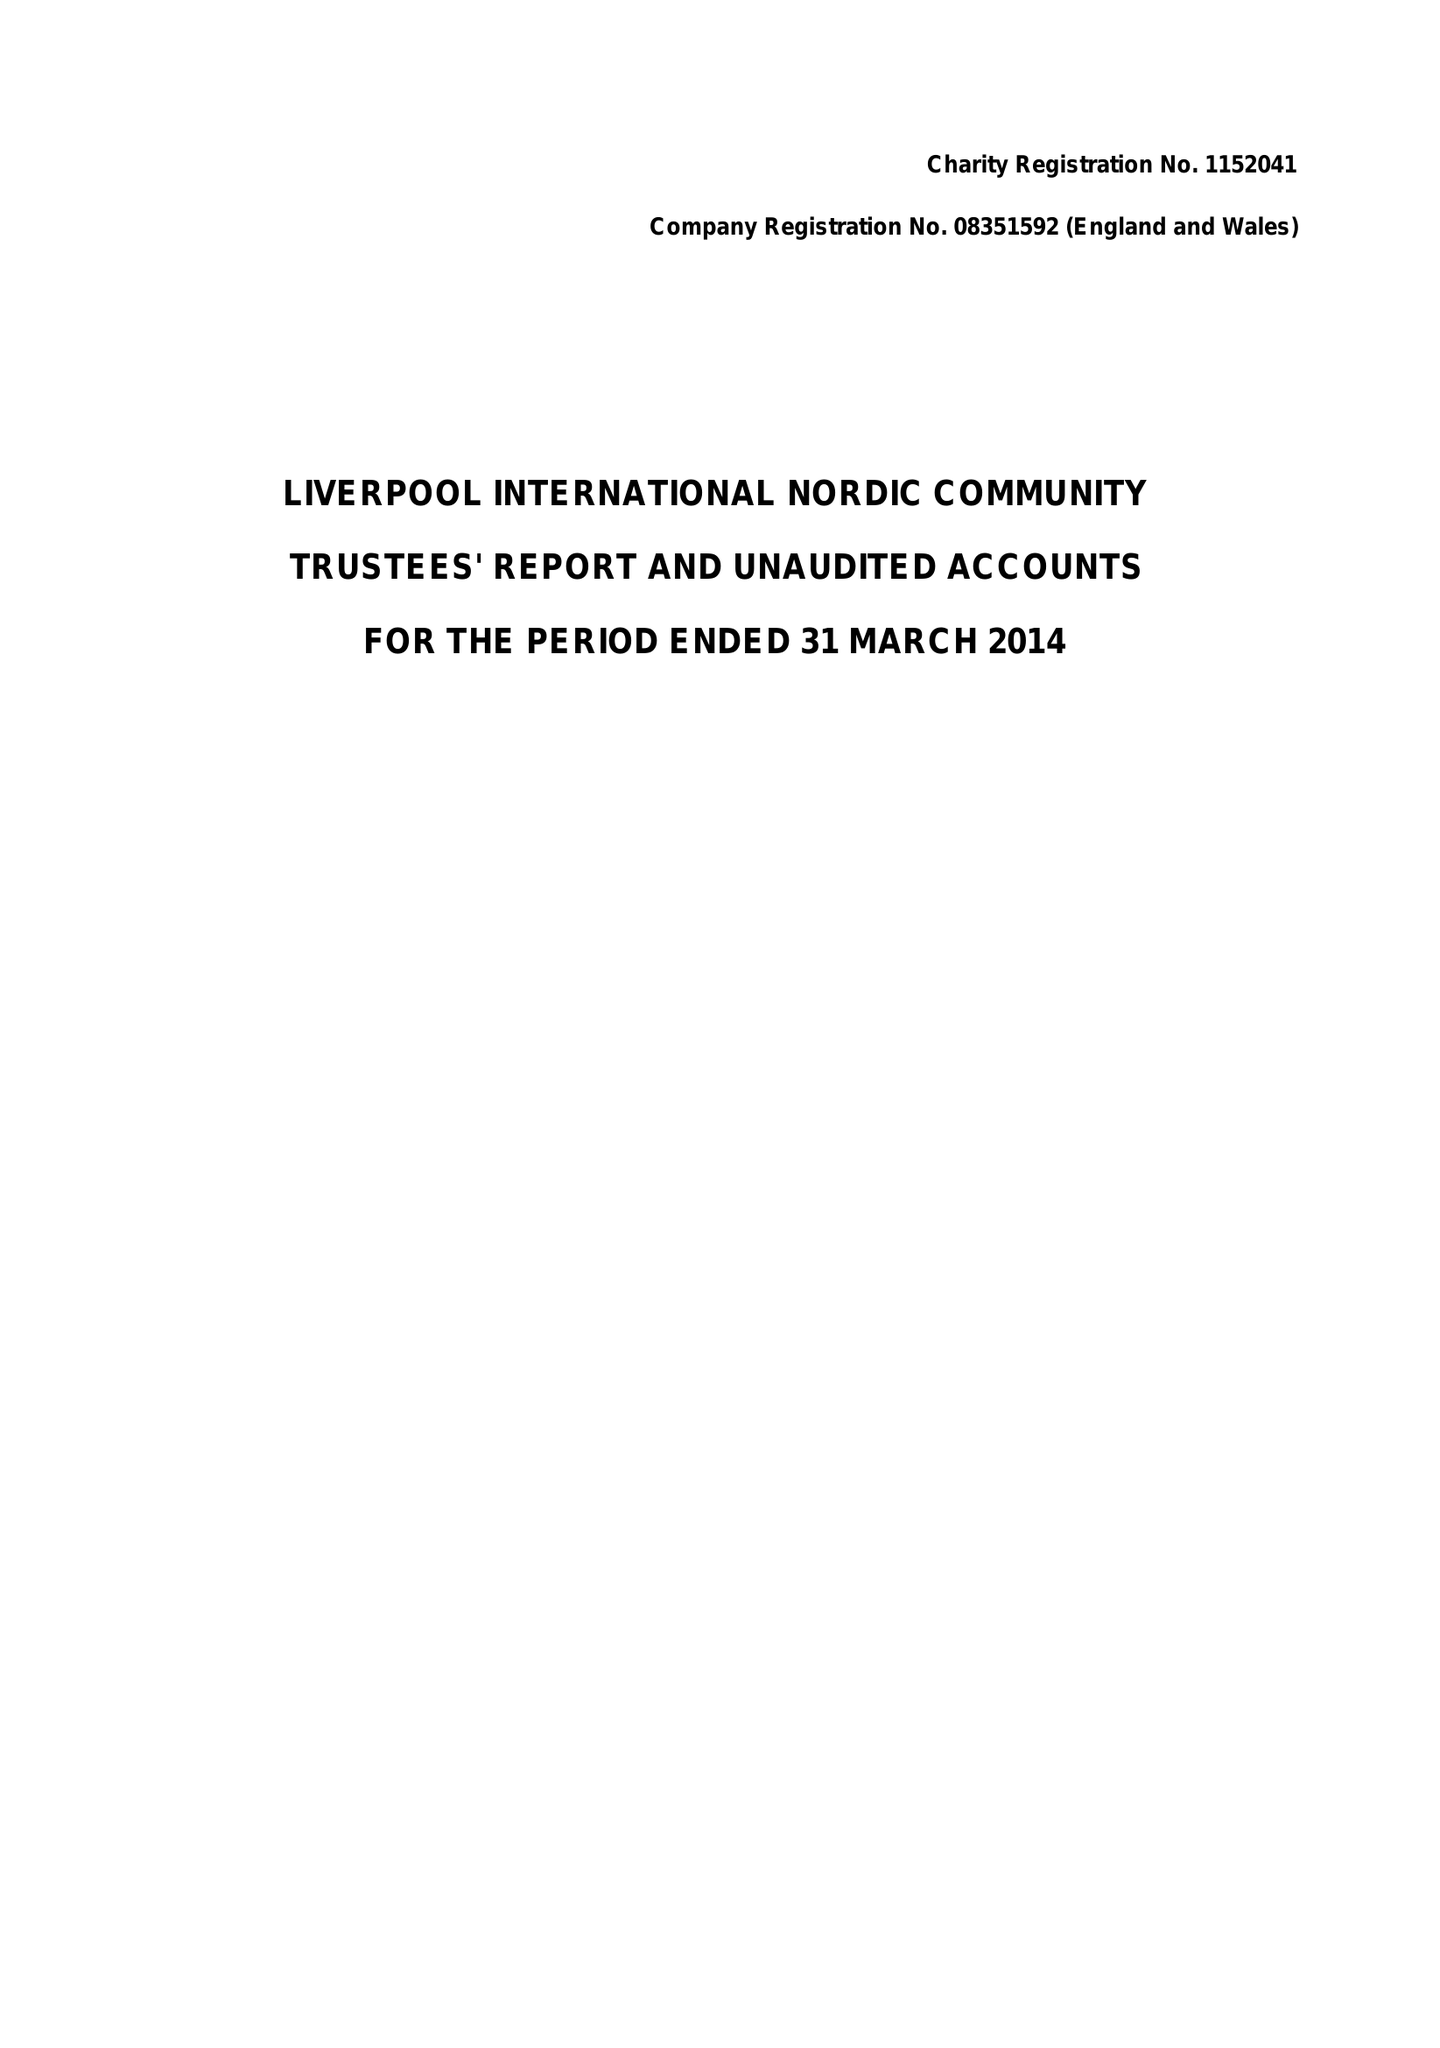What is the value for the charity_name?
Answer the question using a single word or phrase. Liverpool International Nordic Community 